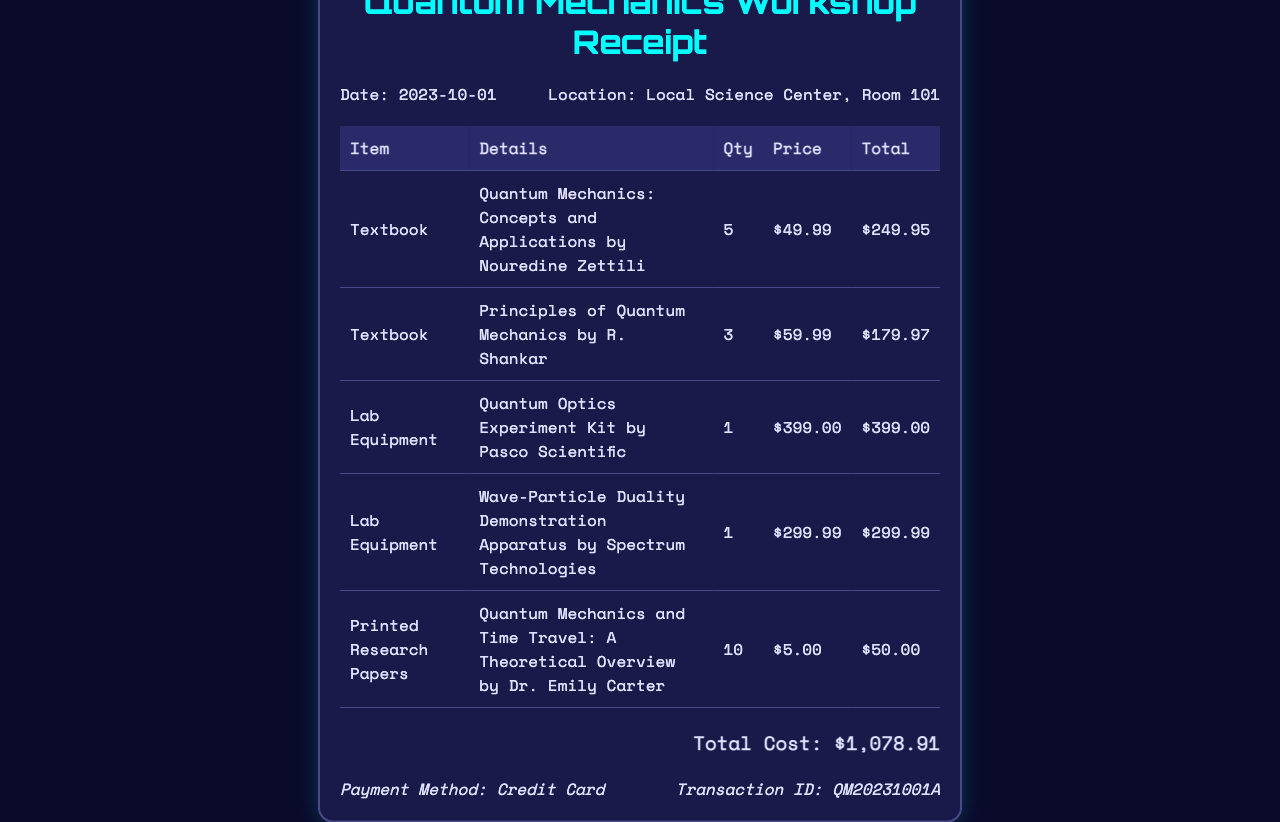What is the date of the workshop? The receipt states the date of the workshop as 2023-10-01.
Answer: 2023-10-01 What is the location of the workshop? The receipt specifies the location as Local Science Center, Room 101.
Answer: Local Science Center, Room 101 How many copies of "Quantum Mechanics: Concepts and Applications" were purchased? The document indicates that 5 copies of the textbook were acquired.
Answer: 5 What is the total cost of all items listed in the receipt? The total cost is given as $1,078.91 at the bottom of the document.
Answer: $1,078.91 What lab equipment costs the most? The Quantum Optics Experiment Kit by Pasco Scientific is listed with the highest price of $399.00.
Answer: $399.00 How many printed research papers were purchased? The receipt shows that 10 printed research papers were acquired.
Answer: 10 What payment method was used? The document states the payment method as Credit Card.
Answer: Credit Card What is the transaction ID for this purchase? The transaction ID is provided as QM20231001A in the payment information section.
Answer: QM20231001A What is the price of the "Wave-Particle Duality Demonstration Apparatus"? The document lists the price of this lab equipment as $299.99.
Answer: $299.99 